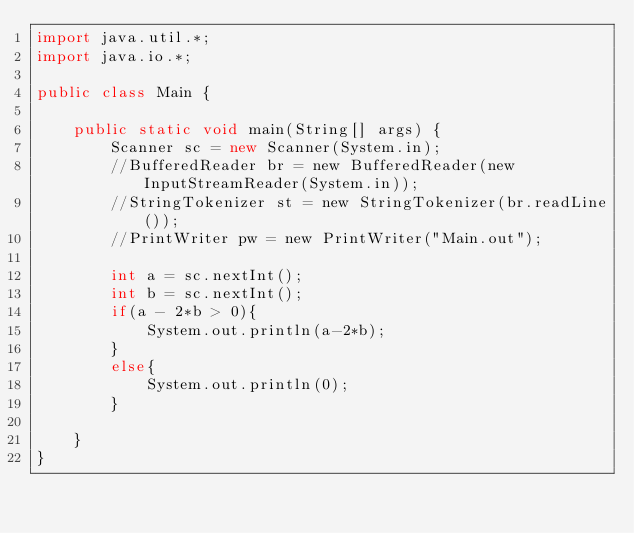<code> <loc_0><loc_0><loc_500><loc_500><_Java_>import java.util.*;
import java.io.*;

public class Main {

    public static void main(String[] args) {
        Scanner sc = new Scanner(System.in);
        //BufferedReader br = new BufferedReader(new InputStreamReader(System.in));
        //StringTokenizer st = new StringTokenizer(br.readLine());
        //PrintWriter pw = new PrintWriter("Main.out");

        int a = sc.nextInt();
        int b = sc.nextInt();
        if(a - 2*b > 0){
            System.out.println(a-2*b);
        }
        else{
            System.out.println(0);
        }

    }
}</code> 